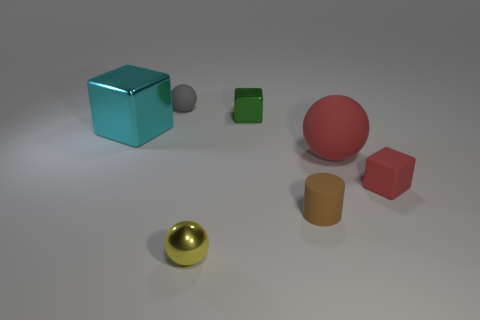What size is the matte sphere in front of the small shiny object right of the metal ball? The matte sphere in the foreground, positioned in front of the small shiny cube and to the right of the metallic ball, appears to be of medium size relative to the other objects in the image. 